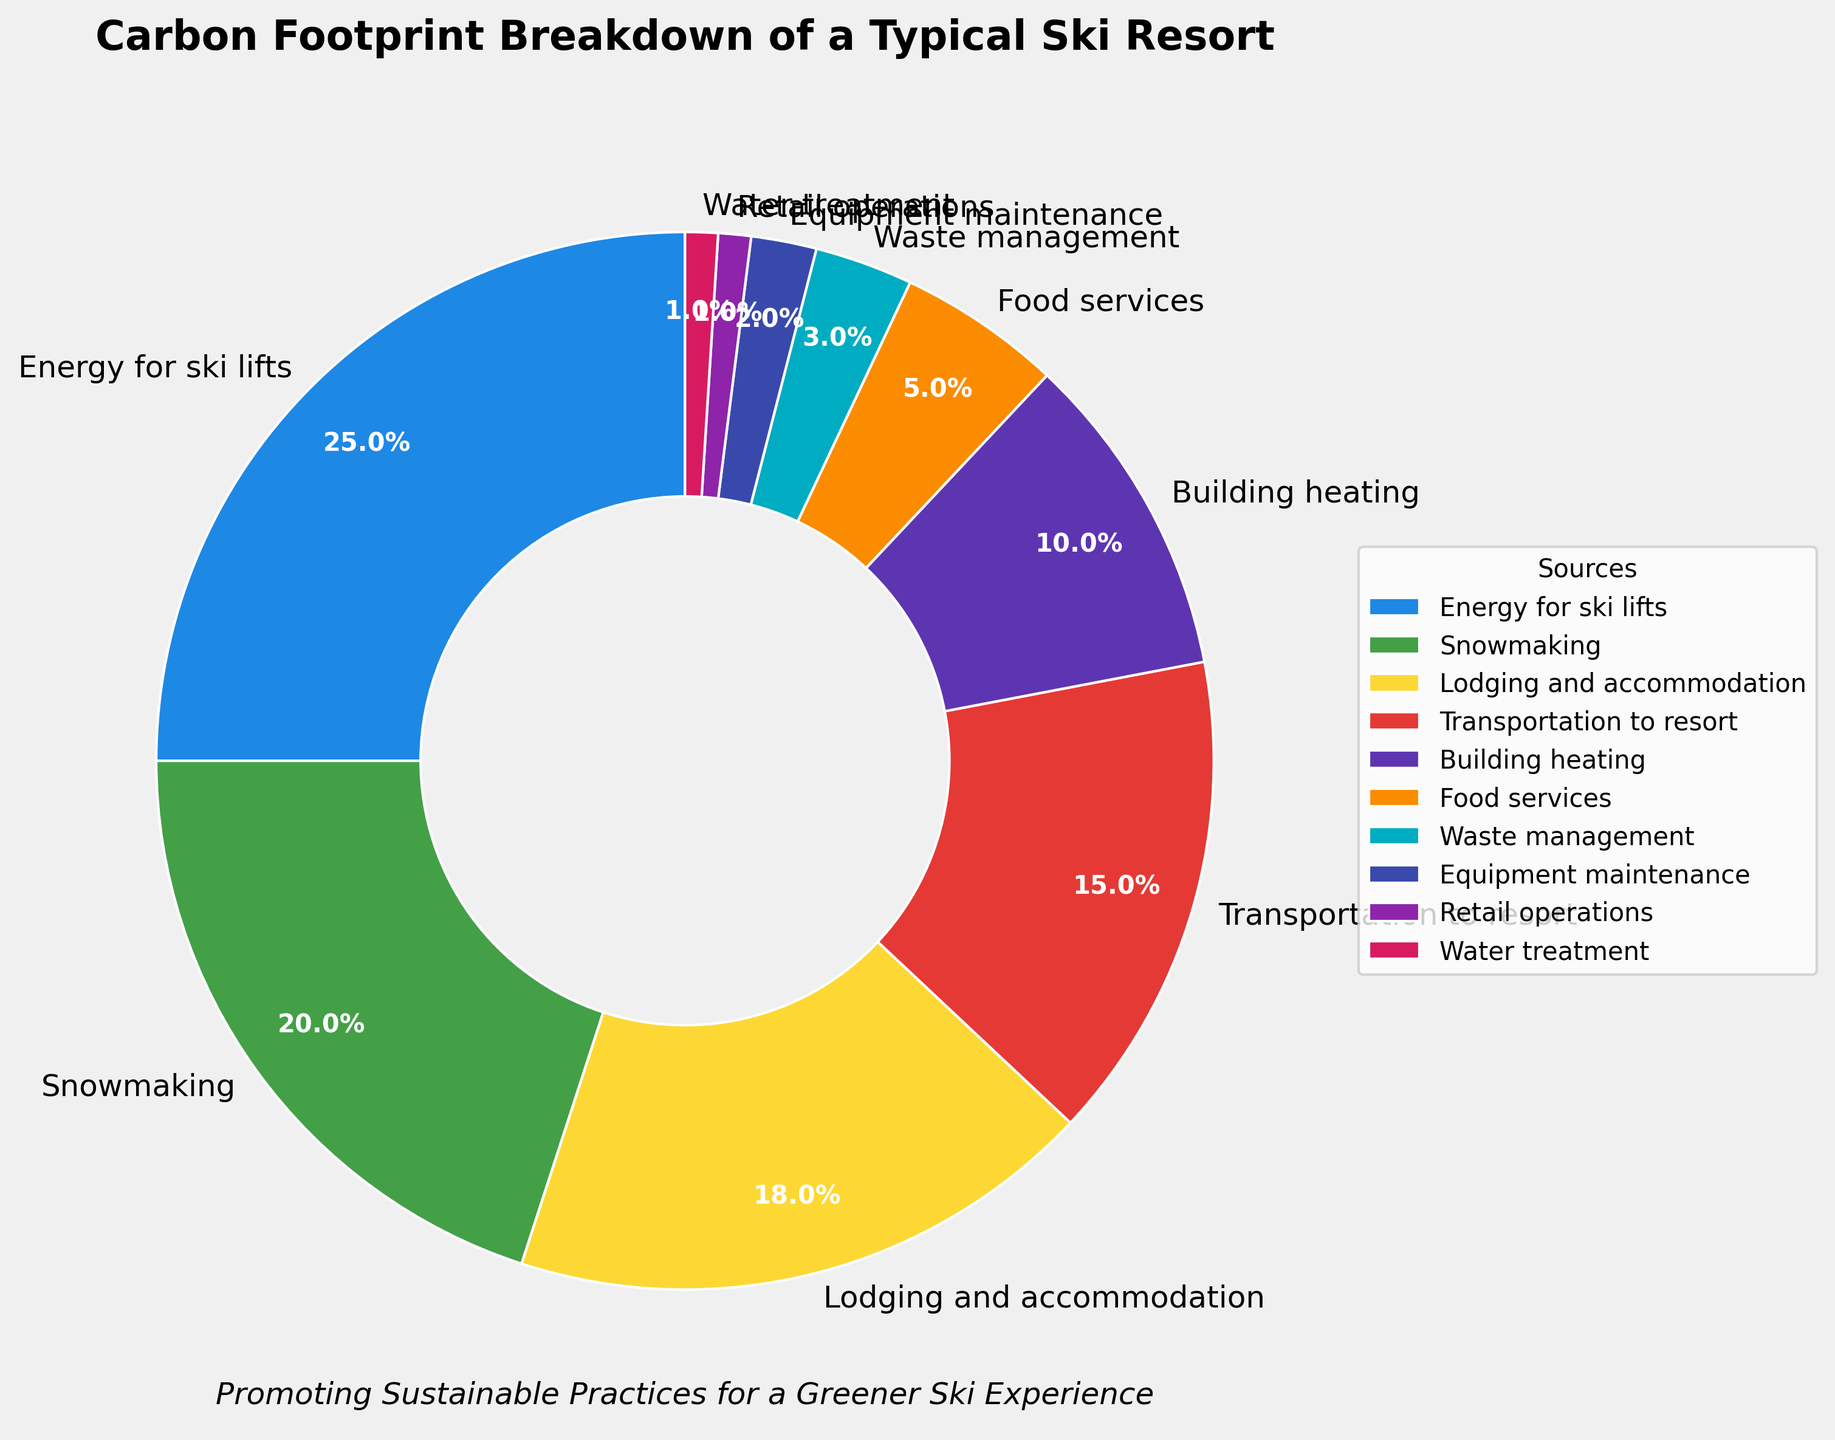Which source contributes the most to the carbon footprint of the ski resort? The figure shows different sources and their respective percentages. The largest slice in the pie chart corresponds to 'Energy for ski lifts' with 25%.
Answer: Energy for ski lifts How much more does snowmaking contribute to the carbon footprint compared to retail operations? The percentage for snowmaking is 20% and for retail operations is 1%. The difference between them is 20% - 1% = 19%.
Answer: 19% What are the combined contributions of lodging and accommodation, and building heating to the carbon footprint? Lodging and accommodation contribute 18% and building heating contributes 10%. Their combined contribution is 18% + 10% = 28%.
Answer: 28% Which source has the smallest contribution to the carbon footprint, and what is its percentage? The smallest slice in the pie chart corresponds to 'Water treatment' with 1%.
Answer: Water treatment, 1% Compare the contributions of transportation to the resort and food services. Which is higher and by how much? Transportation to the resort contributes 15% and food services contribute 5%. Transportation is higher by 15% - 5% = 10%.
Answer: Transportation to resort, 10% What is the combined percentage of the four smallest contributors to the carbon footprint? The four smallest contributors are retail operations (1%), water treatment (1%), equipment maintenance (2%), and waste management (3%). Their combined percentage is 1% + 1% + 2% + 3% = 7%.
Answer: 7% Are there any sources that contribute equally to the carbon footprint? The figure shows that both retail operations and water treatment contribute 1% each.
Answer: Yes, retail operations and water treatment What percentage of the carbon footprint is attributed to activities related to snow and infrastructure (snowmaking and building heating)? Snowmaking contributes 20% and building heating contributes 10%. Their combined contribution is 20% + 10% = 30%.
Answer: 30% Which source has a larger carbon footprint contribution: waste management or equipment maintenance? Waste management contributes 3% and equipment maintenance contributes 2%. Waste management is larger.
Answer: Waste management 